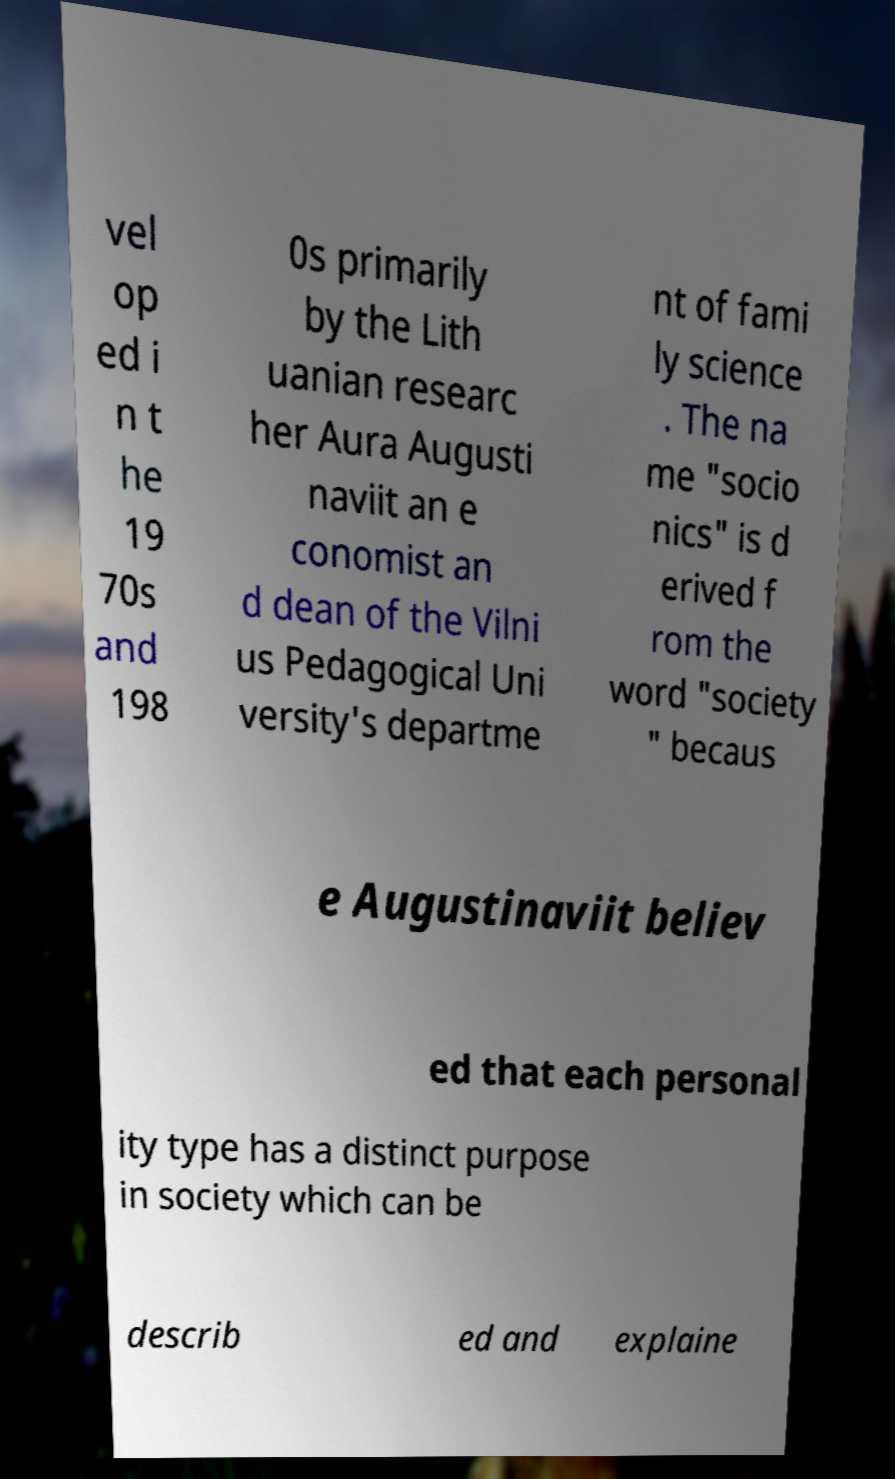What messages or text are displayed in this image? I need them in a readable, typed format. vel op ed i n t he 19 70s and 198 0s primarily by the Lith uanian researc her Aura Augusti naviit an e conomist an d dean of the Vilni us Pedagogical Uni versity's departme nt of fami ly science . The na me "socio nics" is d erived f rom the word "society " becaus e Augustinaviit believ ed that each personal ity type has a distinct purpose in society which can be describ ed and explaine 